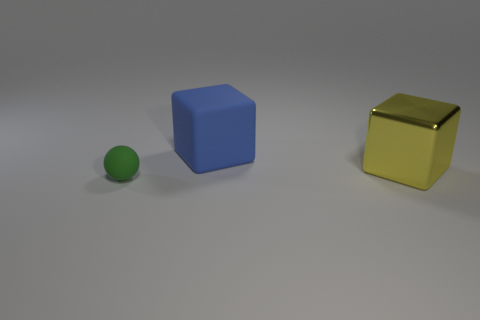Is there anything else that is made of the same material as the large yellow cube?
Keep it short and to the point. No. How many other objects are the same shape as the tiny thing?
Ensure brevity in your answer.  0. Does the matte object right of the tiny matte thing have the same size as the block that is in front of the big rubber block?
Keep it short and to the point. Yes. How many spheres are yellow metal objects or tiny green matte objects?
Offer a terse response. 1. What number of shiny things are tiny green objects or small cyan balls?
Make the answer very short. 0. Is there any other thing that is the same size as the yellow metal cube?
Ensure brevity in your answer.  Yes. There is a yellow thing; is its size the same as the matte thing that is behind the small green object?
Your answer should be compact. Yes. The large thing that is to the left of the large yellow block has what shape?
Your response must be concise. Cube. There is a thing that is to the left of the rubber thing to the right of the ball; what is its color?
Offer a terse response. Green. What is the color of the other object that is the same shape as the blue thing?
Your answer should be very brief. Yellow. 